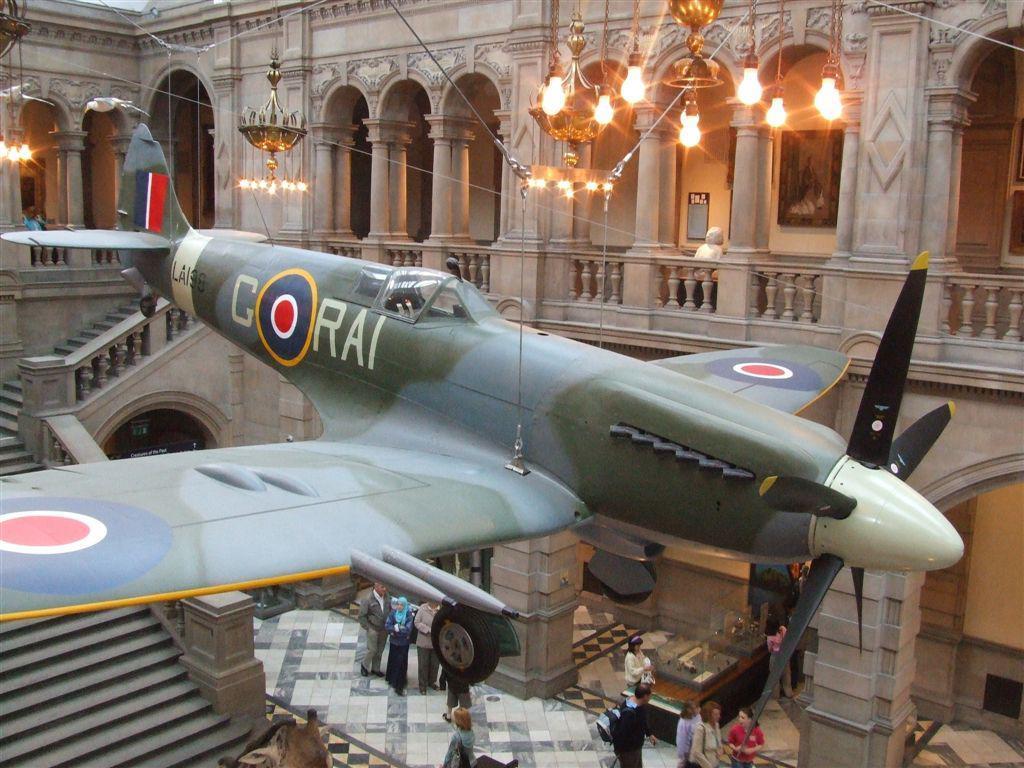Could you give a brief overview of what you see in this image? In this image we can see the inner view of a building and there is an aircraft in the middle of the image. We can see some people at the bottom of the image. 